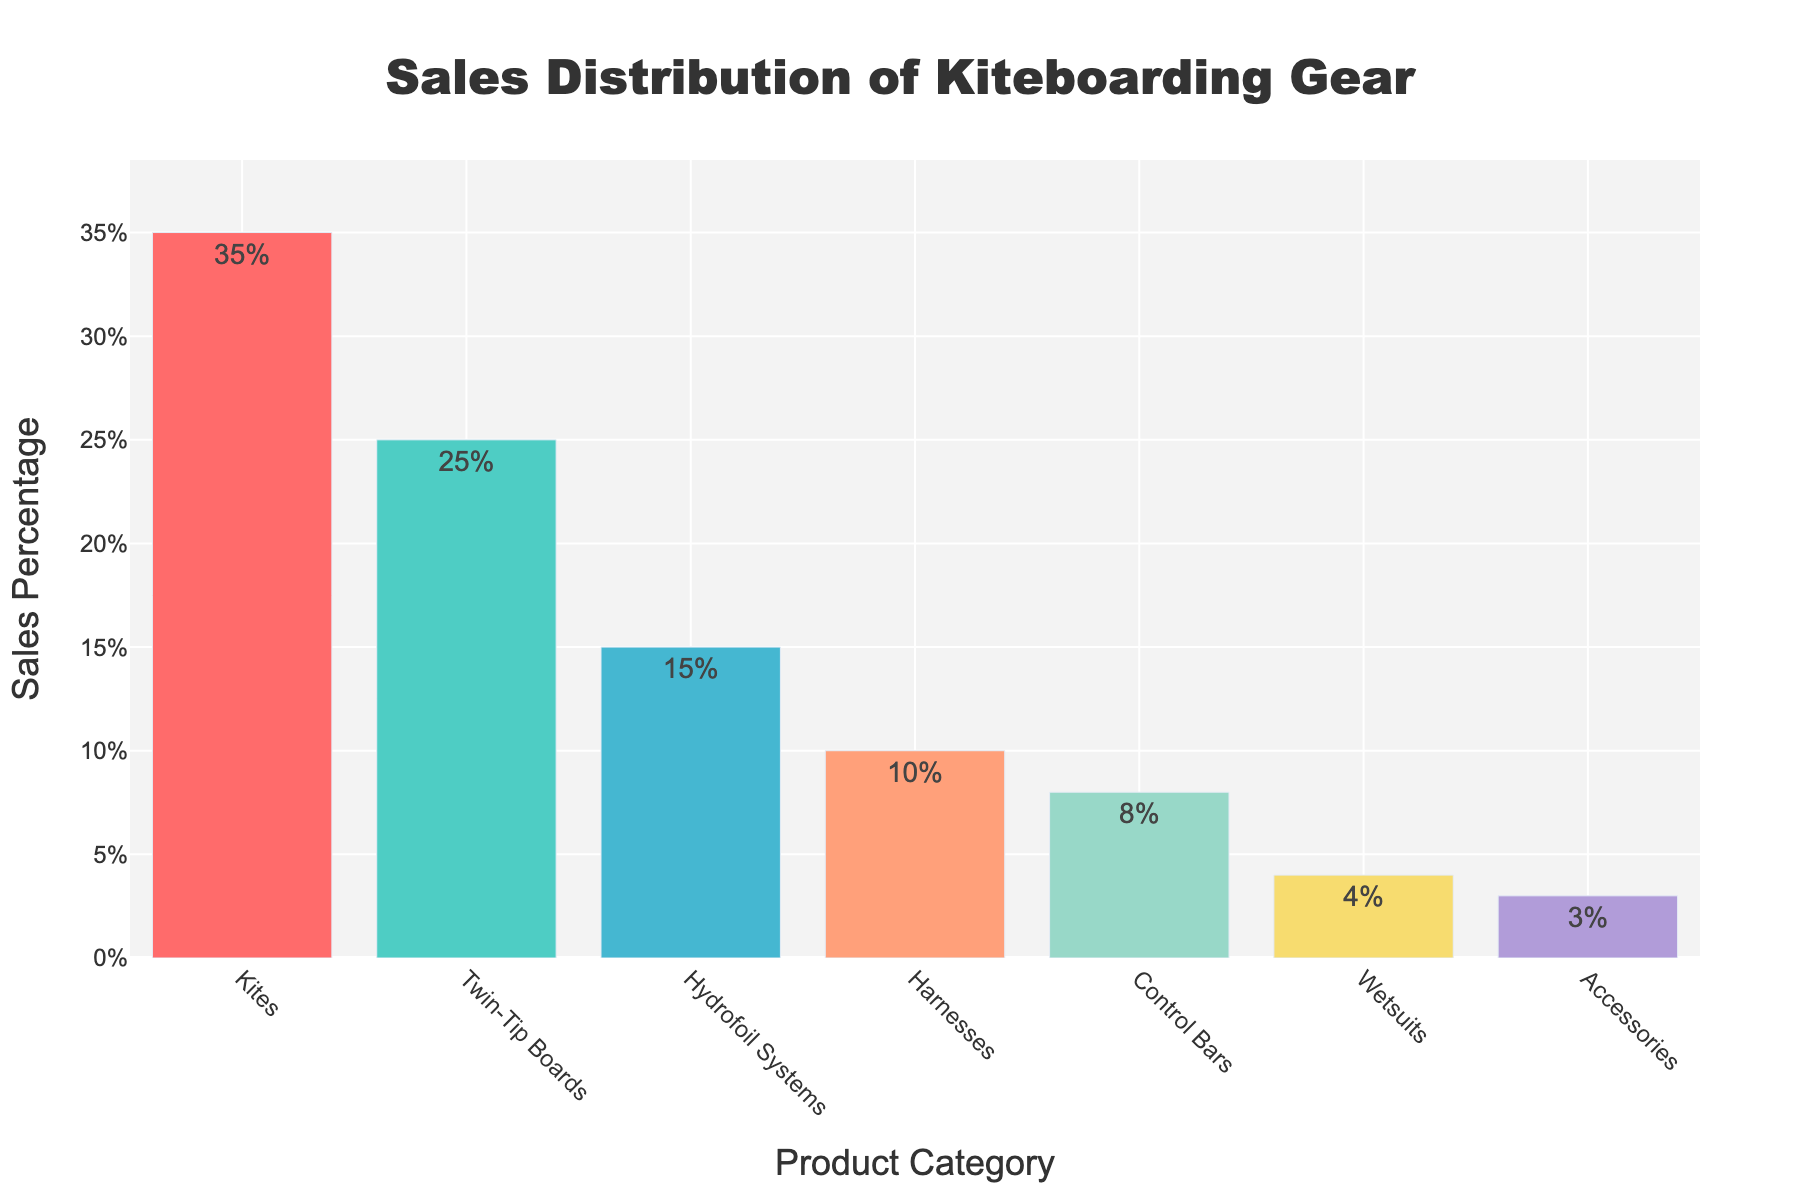Which product category has the highest sales percentage? The highest bar represents the product category with the highest sales percentage. The height of the bar for "Kites" is the tallest.
Answer: Kites What's the total sales percentage of Hydrofoil Systems and Accessories combined? Add the sales percentages of Hydrofoil Systems (15%) and Accessories (3%). 15% + 3% = 18%
Answer: 18% How do the sales percentages of Control Bars compare to Harnesses? Compare the heights of the bars of Control Bars (8%) and Harnesses (10%). The bar for Harnesses is higher.
Answer: Harnesses have more sales than Control Bars What is the difference in sales percentage between Twin-Tip Boards and Wetsuits? Subtract the sales percentage of Wetsuits (4%) from Twin-Tip Boards (25%). 25% - 4% = 21%
Answer: 21% Which product category occupies the smallest portion of sales? The shortest bar represents the product category with the smallest sales percentage. The bar for Accessories is the shortest.
Answer: Accessories What's the average sales percentage of the top three product categories? Add the sales percentages of the top three product categories: Kites (35%), Twin-Tip Boards (25%), and Hydrofoil Systems (15%), then divide by 3. (35% + 25% + 15%) / 3 = 25%
Answer: 25% If we exclude Kites, which product category has the highest sales percentage? Exclude the bar for Kites and then find the highest bar. Twin-Tip Boards have the highest bar after excluding Kites.
Answer: Twin-Tip Boards Compare the total sales percentage of Control Bars and Wetsuits to the sales percentage for Harnesses. Add the sales percentages of Control Bars (8%) and Wetsuits (4%). 8% + 4% = 12%, then compare with Harnesses (10%). 12% > 10%
Answer: 12% (higher than Harnesses) Which product categories have less than or equal to 10% sales percentage? Identify bars with sales percentages of 10% or less. These are Harnesses, Control Bars, Wetsuits, and Accessories.
Answer: Harnesses, Control Bars, Wetsuits, Accessories What's the combined sales percentage for all the product categories? Sum the sales percentages of all product categories: 35% (Kites) + 25% (Twin-Tip Boards) + 15% (Hydrofoil Systems) + 10% (Harnesses) + 8% (Control Bars) + 4% (Wetsuits) + 3% (Accessories) = 100%
Answer: 100% 